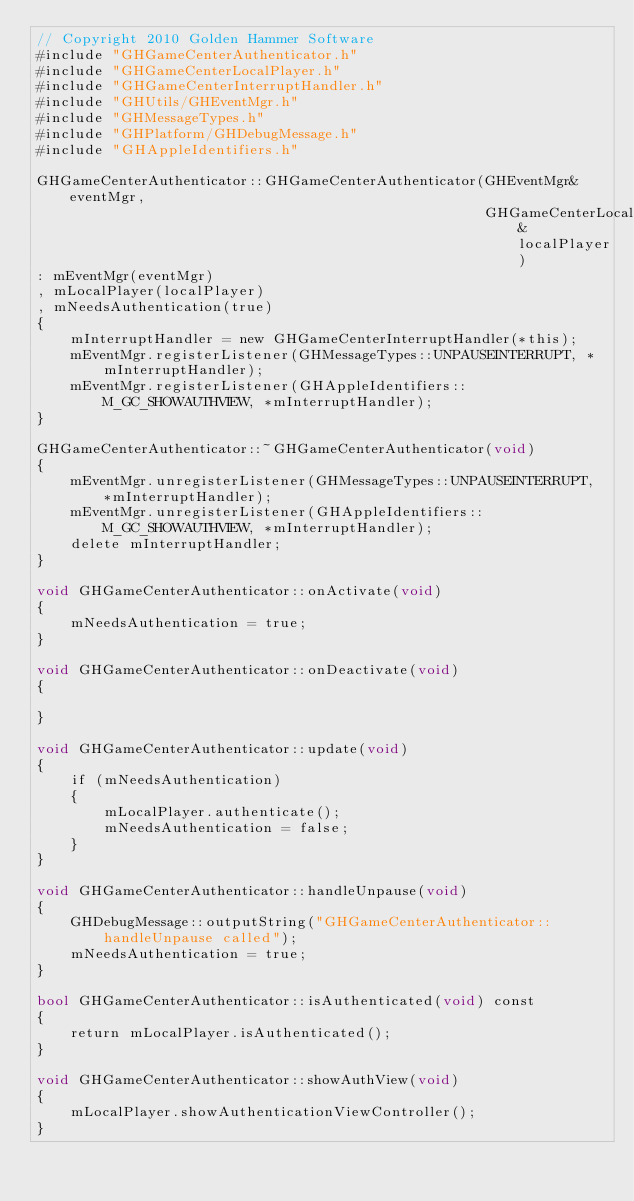<code> <loc_0><loc_0><loc_500><loc_500><_ObjectiveC_>// Copyright 2010 Golden Hammer Software
#include "GHGameCenterAuthenticator.h"
#include "GHGameCenterLocalPlayer.h"
#include "GHGameCenterInterruptHandler.h"
#include "GHUtils/GHEventMgr.h"
#include "GHMessageTypes.h"
#include "GHPlatform/GHDebugMessage.h"
#include "GHAppleIdentifiers.h"

GHGameCenterAuthenticator::GHGameCenterAuthenticator(GHEventMgr& eventMgr,
                                                     GHGameCenterLocalPlayer& localPlayer)
: mEventMgr(eventMgr)
, mLocalPlayer(localPlayer)
, mNeedsAuthentication(true)
{
    mInterruptHandler = new GHGameCenterInterruptHandler(*this);
    mEventMgr.registerListener(GHMessageTypes::UNPAUSEINTERRUPT, *mInterruptHandler);
    mEventMgr.registerListener(GHAppleIdentifiers::M_GC_SHOWAUTHVIEW, *mInterruptHandler);
}

GHGameCenterAuthenticator::~GHGameCenterAuthenticator(void)
{
    mEventMgr.unregisterListener(GHMessageTypes::UNPAUSEINTERRUPT, *mInterruptHandler);
    mEventMgr.unregisterListener(GHAppleIdentifiers::M_GC_SHOWAUTHVIEW, *mInterruptHandler);
    delete mInterruptHandler;
}

void GHGameCenterAuthenticator::onActivate(void)
{
    mNeedsAuthentication = true;
}

void GHGameCenterAuthenticator::onDeactivate(void)
{
    
}

void GHGameCenterAuthenticator::update(void)
{
    if (mNeedsAuthentication)
    {
        mLocalPlayer.authenticate();
        mNeedsAuthentication = false;
    }
}

void GHGameCenterAuthenticator::handleUnpause(void)
{
    GHDebugMessage::outputString("GHGameCenterAuthenticator::handleUnpause called");
    mNeedsAuthentication = true;
}

bool GHGameCenterAuthenticator::isAuthenticated(void) const
{
    return mLocalPlayer.isAuthenticated();
}

void GHGameCenterAuthenticator::showAuthView(void)
{
    mLocalPlayer.showAuthenticationViewController();
}
</code> 